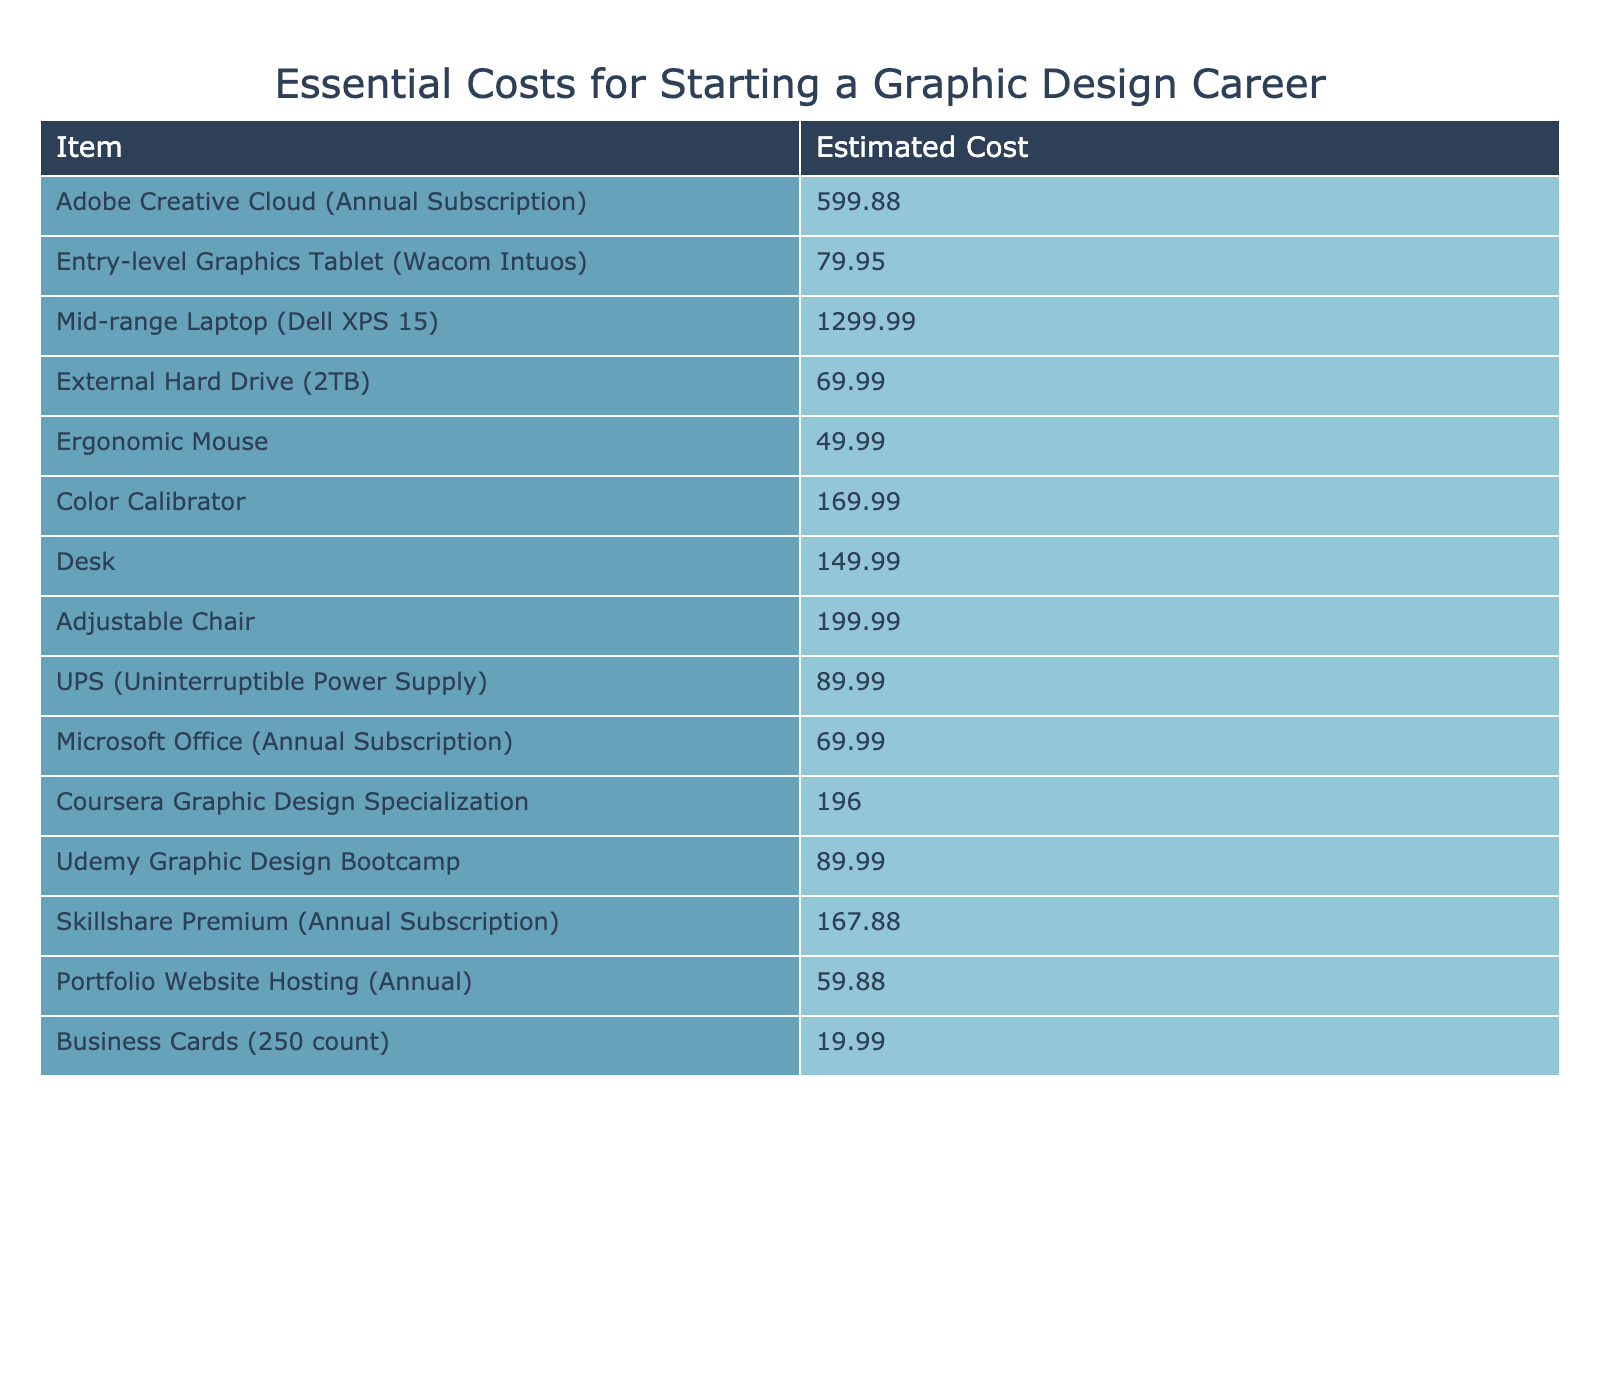What is the estimated cost of Adobe Creative Cloud? The table lists the estimated cost of Adobe Creative Cloud, which is explicitly stated as 599.88.
Answer: 599.88 How much does a mid-range laptop cost? According to the table, the cost of a mid-range laptop (Dell XPS 15) is mentioned as 1299.99.
Answer: 1299.99 What is the total estimated cost for a graphics tablet, ergonomic mouse, and external hard drive? The total cost can be calculated by adding the costs of the three items: 79.95 (graphics tablet) + 49.99 (ergonomic mouse) + 69.99 (external hard drive) = 199.93.
Answer: 199.93 Is the cost of a color calibrator higher than the cost of an ergonomic mouse? The cost of the color calibrator is 169.99, and the ergonomic mouse costs 49.99. Since 169.99 is greater than 49.99, the statement is true.
Answer: Yes What is the average cost of the two software subscriptions: Microsoft Office and Skillshare Premium? First, we find the individual costs: Microsoft Office is 69.99 and Skillshare Premium is 167.88. The average is calculated as (69.99 + 167.88) / 2 = 118.935.
Answer: 118.935 What is the total estimated cost of starting a graphic design career including all items in the table? To find the total, we need to sum the estimated costs of all items listed in the table. The total is calculated as 599.88 + 79.95 + 1299.99 + 69.99 + 49.99 + 169.99 + 149.99 + 199.99 + 89.99 + 69.99 + 196.00 + 89.99 + 167.88 + 59.88 + 19.99 = 2481.12.
Answer: 2481.12 Is the cost of hosting a portfolio website less than that of business cards? The cost for portfolio website hosting is 59.88, while the cost of business cards is 19.99. Since 59.88 is greater than 19.99, the statement is false.
Answer: No If you add the costs of the adjustable chair and desk, how much do you get? The cost of the adjustable chair is 199.99, and the desk costs 149.99. Adding these gives 199.99 + 149.99 = 349.98.
Answer: 349.98 What is the difference in cost between the Coursera Graphic Design Specialization and Udemy Graphic Design Bootcamp? Coursera costs 196.00, while Udemy costs 89.99. The difference is calculated as 196.00 - 89.99 = 106.01.
Answer: 106.01 If you were to buy all items listed, which component would be the most expensive? Looking through the list, the most expensive item is the Mid-range Laptop at 1299.99.
Answer: Mid-range Laptop 